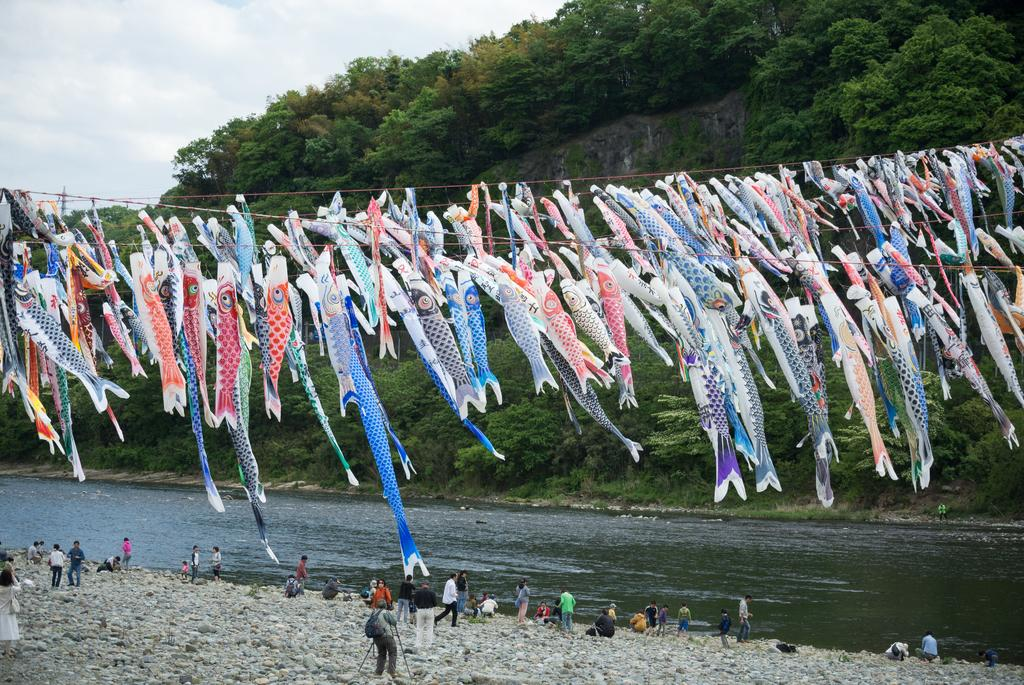What is being hung on ropes in the image? Clothes are hanged on ropes in the image. What type of landscape can be seen in the image? Hills, trees, and a river are visible in the image. What is the condition of the sky in the image? The sky with clouds is visible in the image. What are the people in the image doing? Persons are sitting and standing on the riverbeds. What type of wealth is being displayed in the image? There is no indication of wealth in the image; it features clothes hung on ropes, hills, trees, a river, and people sitting or standing on the riverbeds. What is the common interest among the people in the image? There is no information about the people's interests in the image; they are simply sitting or standing on the riverbeds. 